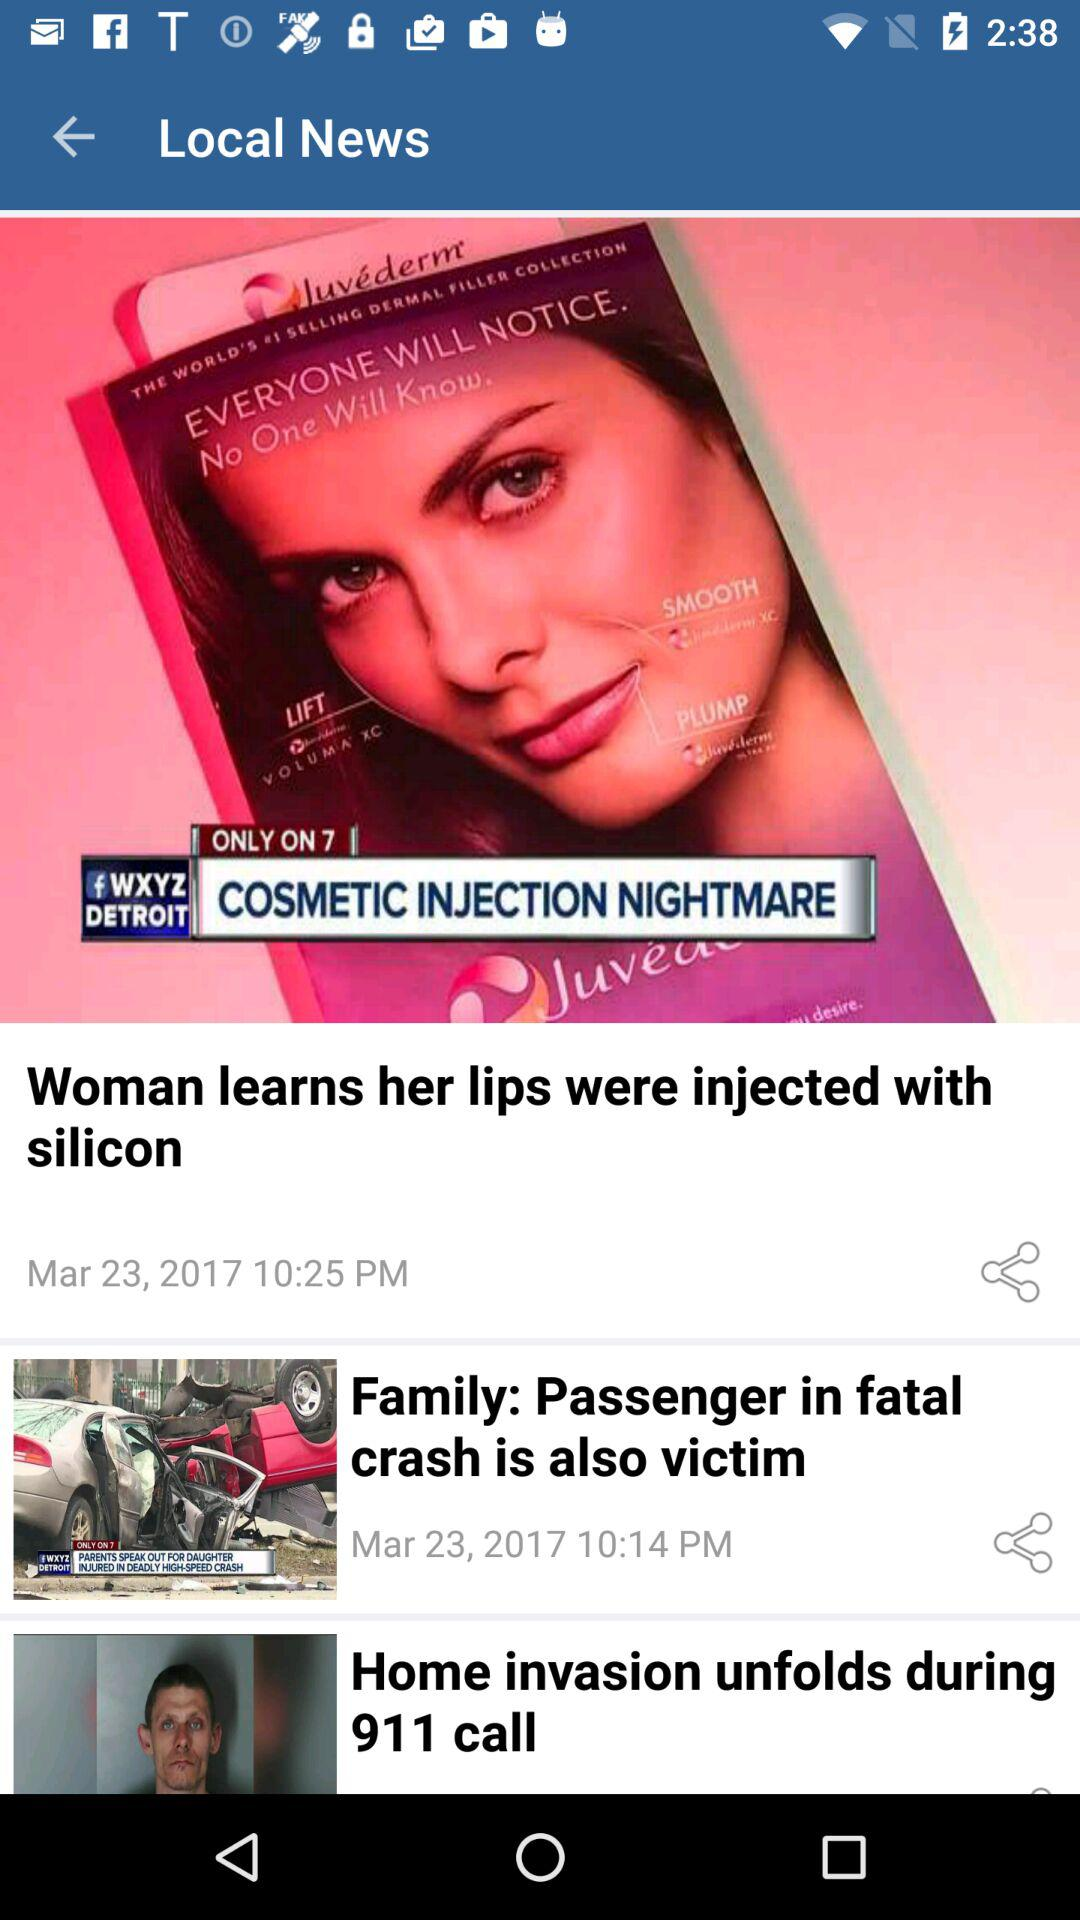What is the posted date of the news "Woman learns her lips were injected with silicon"? The news was posted on March 23, 2017. 